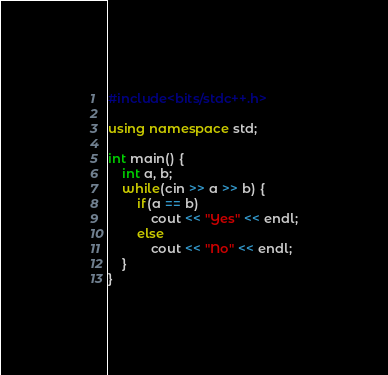<code> <loc_0><loc_0><loc_500><loc_500><_C++_>#include<bits/stdc++.h>

using namespace std;

int main() {
	int a, b;
	while(cin >> a >> b) {
		if(a == b)
			cout << "Yes" << endl;
		else
			cout << "No" << endl;
	}
} </code> 